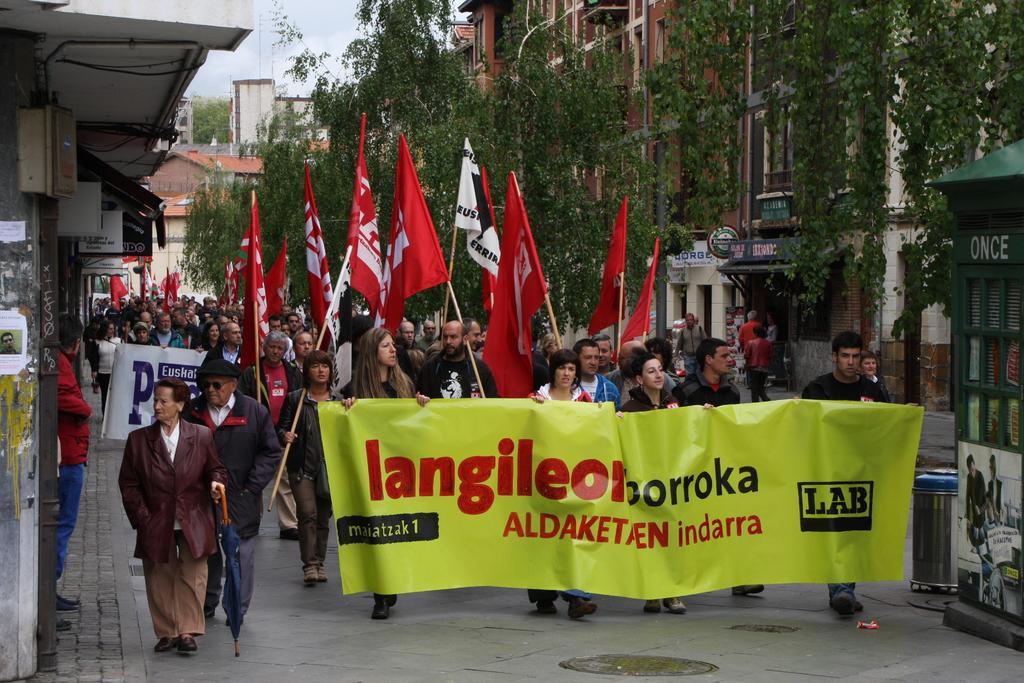Describe this image in one or two sentences. In this picture I can see group of people holding flags and banners, there are buildings, there are trees, and in the background there is the sky. 